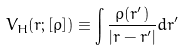<formula> <loc_0><loc_0><loc_500><loc_500>V _ { H } ( { r } ; [ \rho ] ) \equiv \int \frac { \rho ( { r ^ { \prime } } ) } { | { r } - { r ^ { \prime } } | } d { r ^ { \prime } }</formula> 